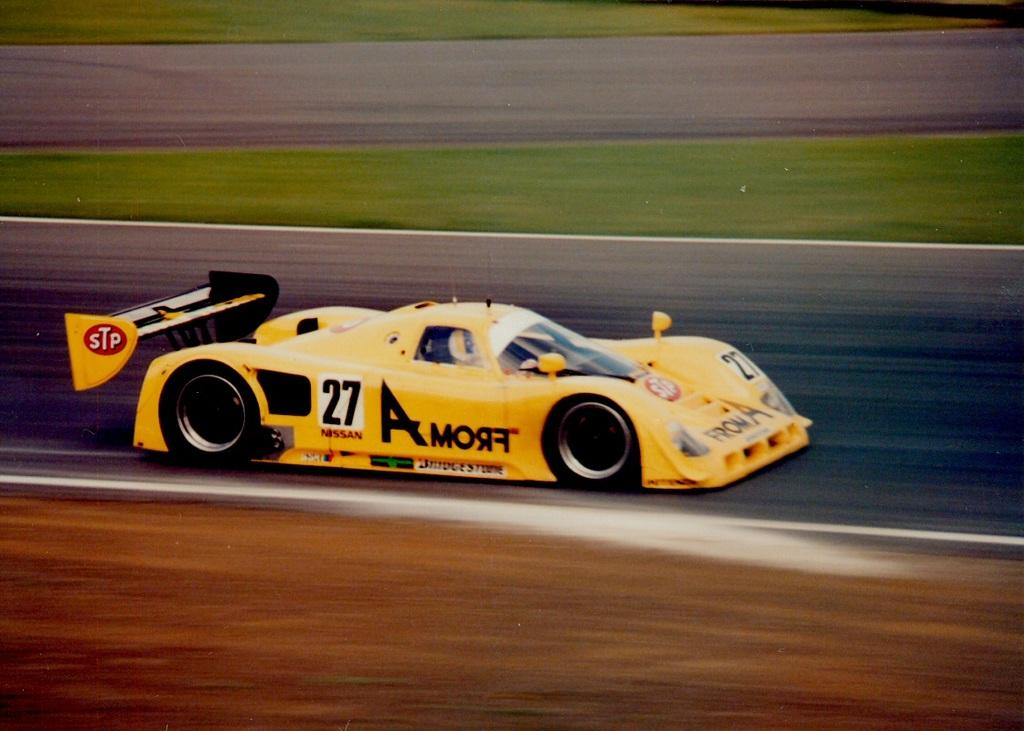What is the main subject of the image? The main subject of the image is a race car. Can you describe the background of the image? The background of the image is blurry. What type of channel is the scarecrow watching in the image? There is no scarecrow or channel present in the image; it features a race car with a blurry background. 